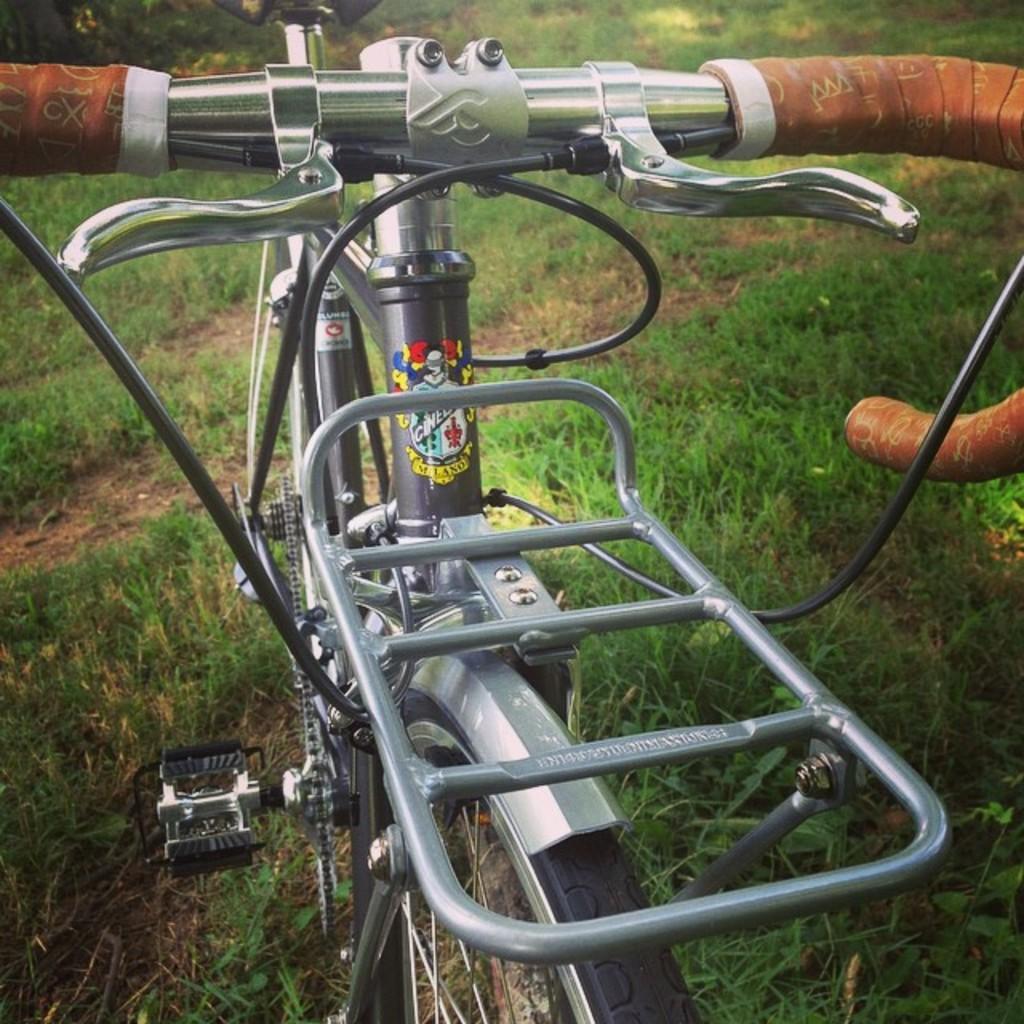In one or two sentences, can you explain what this image depicts? In this image in the foreground there is a cycle, and in the background there is grass. 